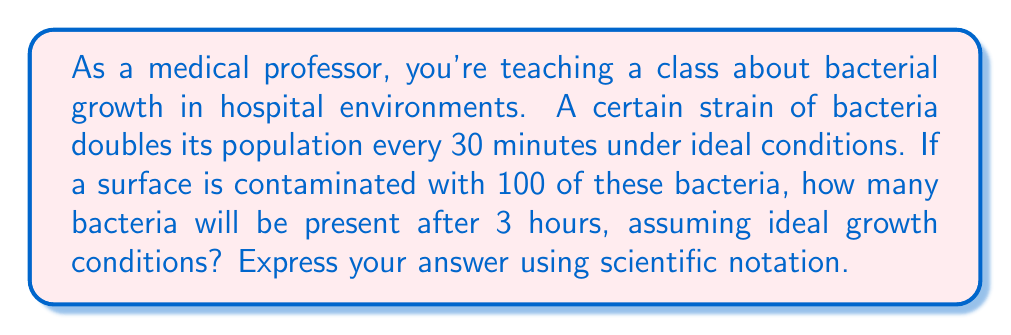Give your solution to this math problem. Let's approach this step-by-step:

1) First, we need to determine how many times the bacteria population will double in 3 hours.
   - 3 hours = 180 minutes
   - The bacteria doubles every 30 minutes
   - Number of doublings = $\frac{180 \text{ minutes}}{30 \text{ minutes per doubling}} = 6$ doublings

2) We can represent this growth using exponents:
   - Initial population: 100
   - Each doubling multiplies the population by 2
   - After 6 doublings: $100 \cdot 2^6$

3) Let's calculate $2^6$:
   $$2^6 = 2 \cdot 2 \cdot 2 \cdot 2 \cdot 2 \cdot 2 = 64$$

4) Now we can find the final population:
   $$100 \cdot 2^6 = 100 \cdot 64 = 6400$$

5) To express this in scientific notation, we move the decimal point to the left until we have a number between 1 and 10, and then count how many places we moved:
   $6400 = 6.4 \cdot 10^3$

Therefore, after 3 hours, there will be $6.4 \cdot 10^3$ bacteria.
Answer: $6.4 \cdot 10^3$ bacteria 